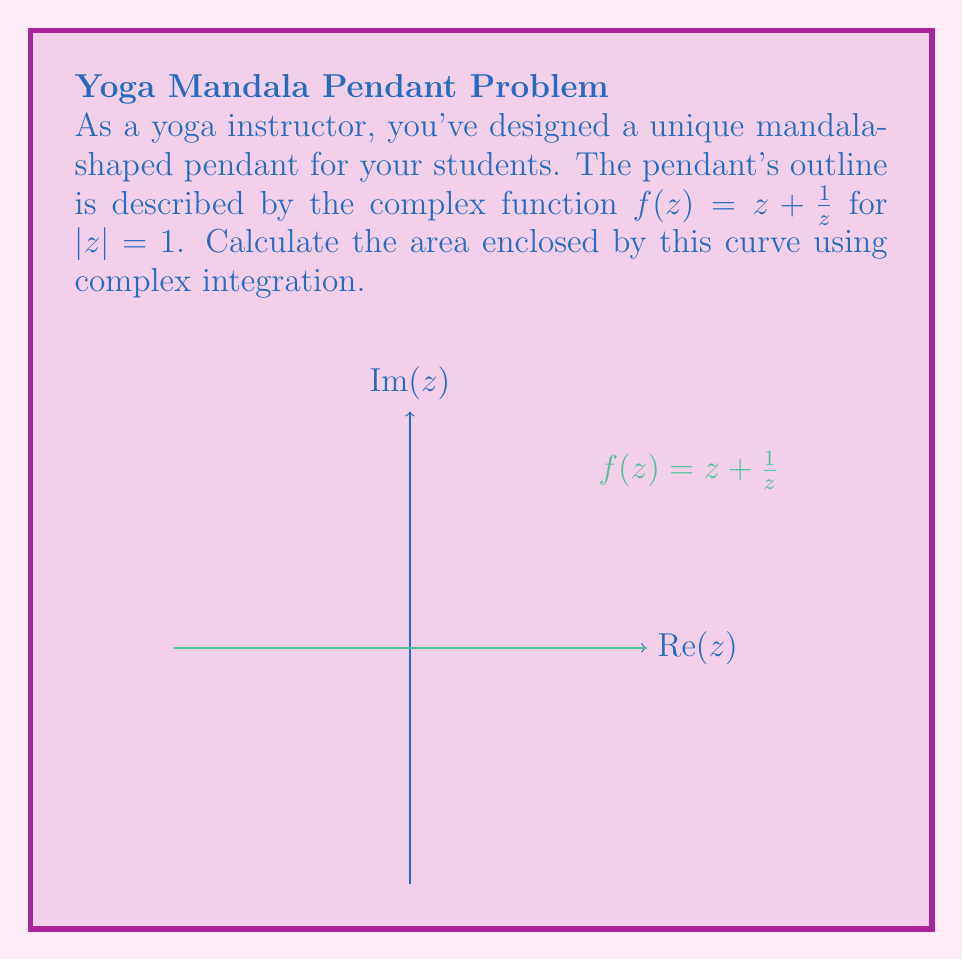What is the answer to this math problem? To solve this problem, we'll use Green's theorem in the complex plane:

1) The area $A$ enclosed by a simple closed curve $C$ is given by:

   $$A = -\frac{1}{2i} \oint_C \bar{z} dz$$

2) In our case, $z = e^{it}$ (since $|z| = 1$) and $dz = ie^{it}dt$

3) We need to express $\bar{z}$ in terms of $z$:
   $f(z) = z + \frac{1}{z} = e^{it} + e^{-it} = 2\cos(t)$
   $\bar{f(z)} = 2\cos(t) = z + \frac{1}{z} = f(z)$

4) Substituting into the integral:

   $$A = -\frac{1}{2i} \oint_C (z + \frac{1}{z}) dz$$

5) Expand the integrand:

   $$A = -\frac{1}{2i} \oint_C (z + \frac{1}{z})(ie^{it}dt)$$

6) Simplify:

   $$A = -\frac{1}{2i} \oint_C (ie^{2it} + i)dt$$

7) Integrate from 0 to $2\pi$:

   $$A = -\frac{1}{2i} [(\frac{1}{2i}e^{2it} + it)]_0^{2\pi}$$

8) Evaluate the limits:

   $$A = -\frac{1}{2i} [(\frac{1}{2i} + 2\pi i) - (\frac{1}{2i})] = \pi$$

Therefore, the area of the mandala-shaped pendant is $\pi$ square units.
Answer: $\pi$ square units 